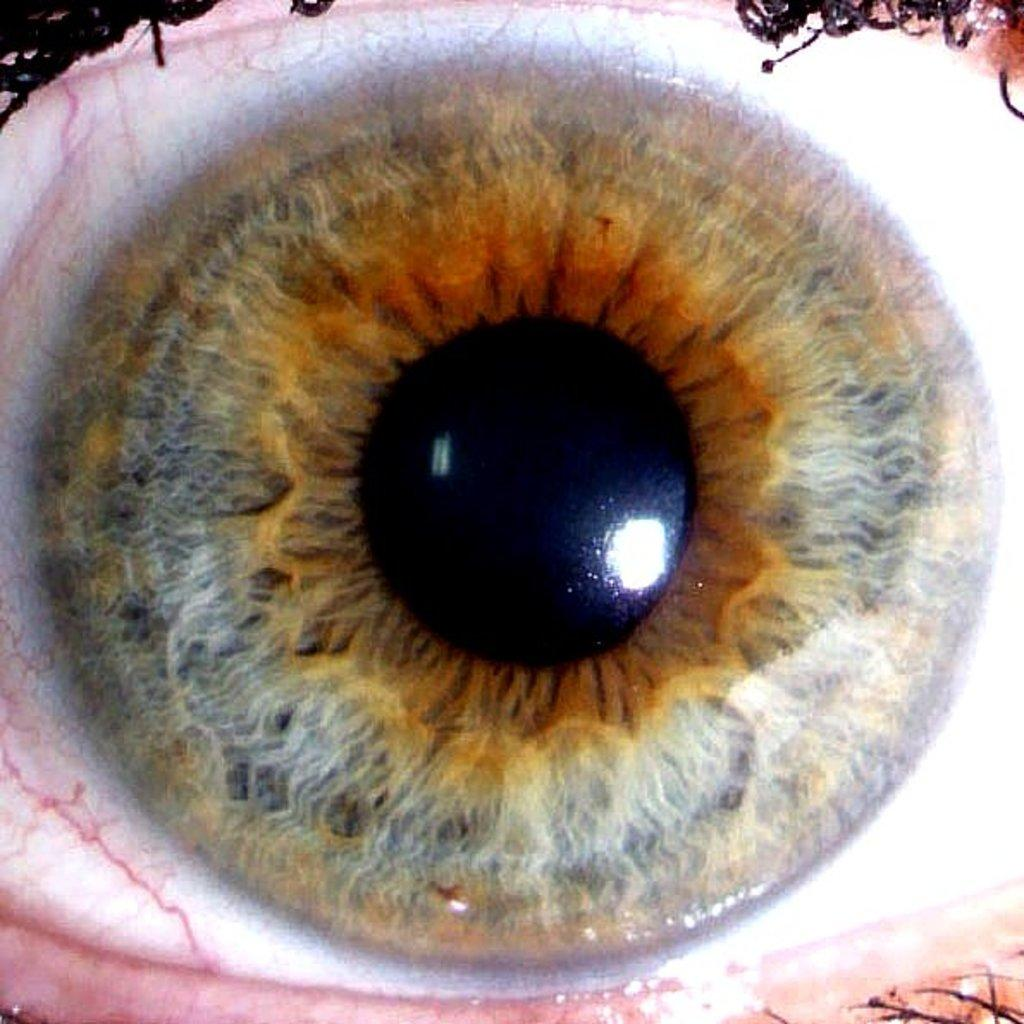What is the main subject of the image? The main subject of the image is the eye of a human. Can you describe the eye in the image? The eye appears to be a close-up view of a human eye. What language is the eye speaking in the image? The eye cannot speak a language, as it is a body part and not a sentient being. 